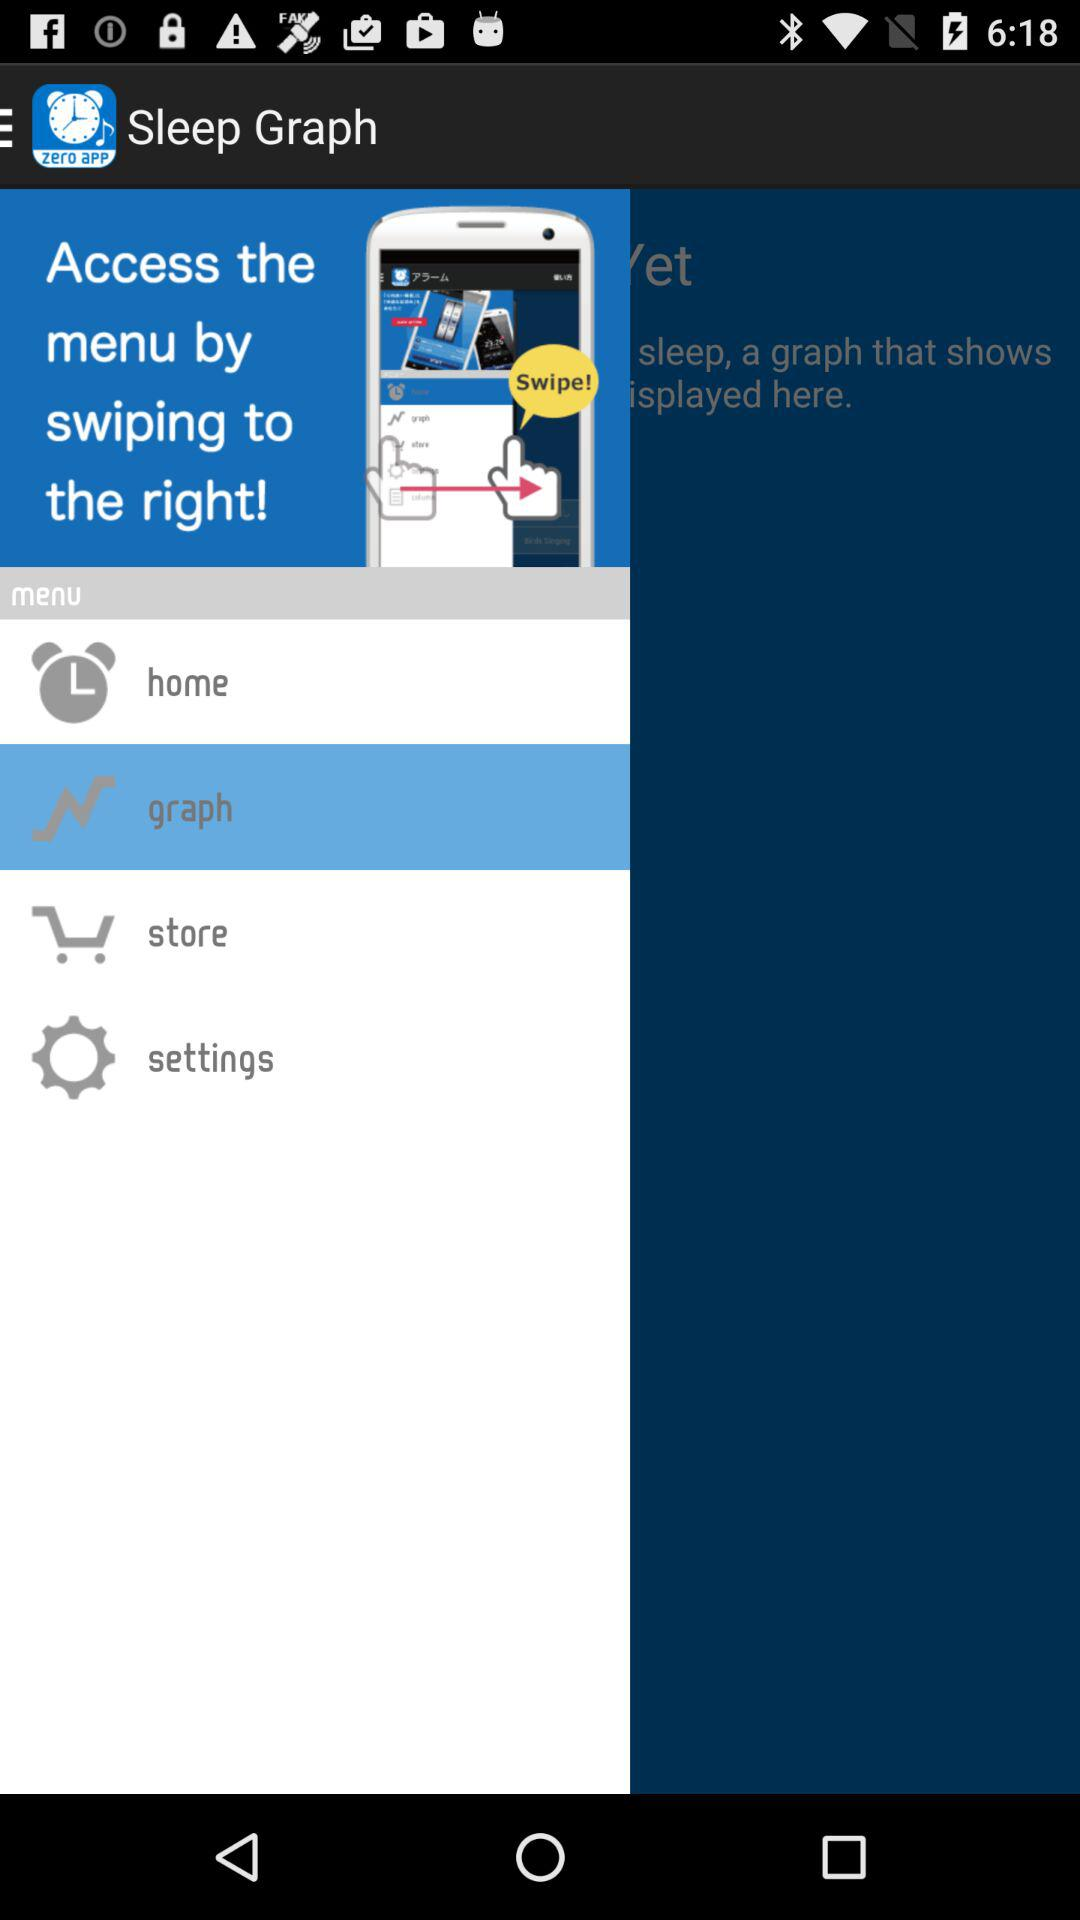Which item is selected? The selected item is "graph". 